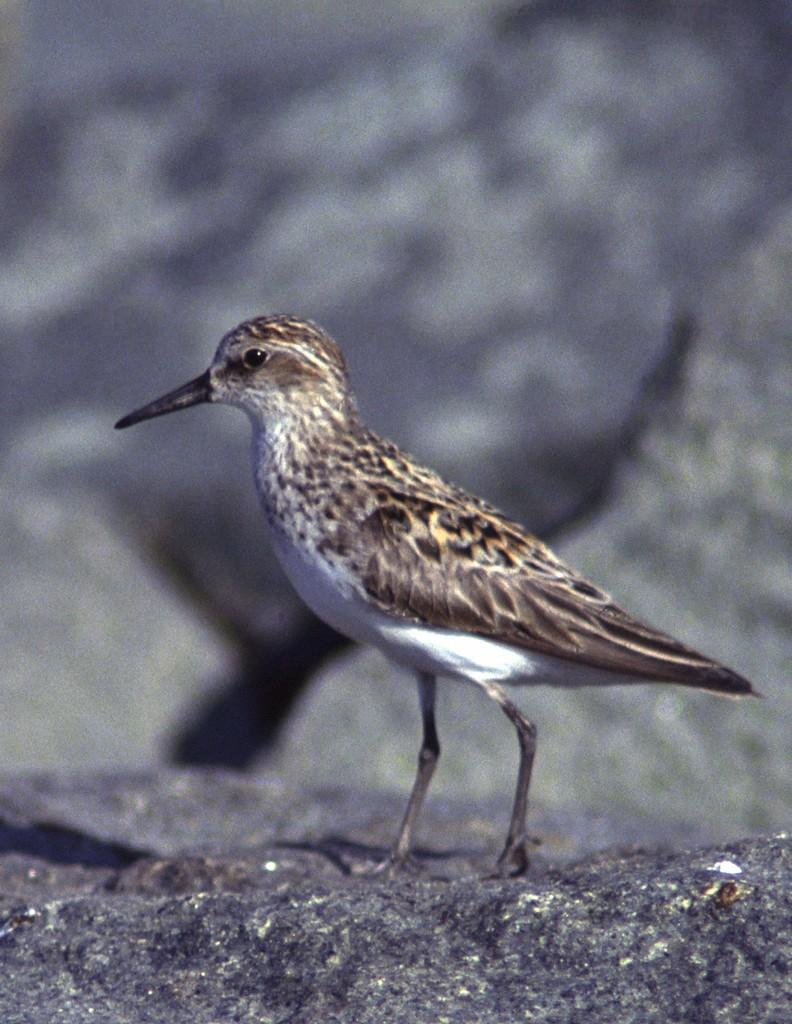What type of animal can be seen in the image? There is a bird in the image. What is the bird standing on? The bird is standing on a rock surface. What color is the background of the image? The background of the image is blue. Where is the control panel for the fan in the image? There is no fan or control panel present in the image; it features a bird standing on a rock surface with a blue background. 